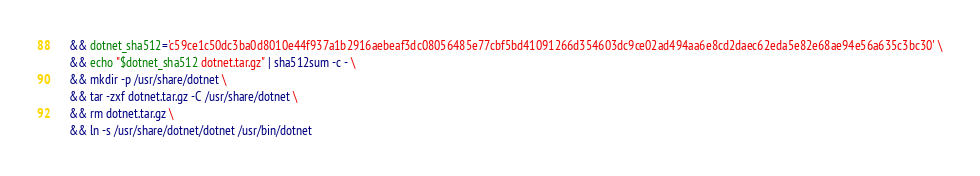Convert code to text. <code><loc_0><loc_0><loc_500><loc_500><_Dockerfile_>    && dotnet_sha512='c59ce1c50dc3ba0d8010e44f937a1b2916aebeaf3dc08056485e77cbf5bd41091266d354603dc9ce02ad494aa6e8cd2daec62eda5e82e68ae94e56a635c3bc30' \
    && echo "$dotnet_sha512 dotnet.tar.gz" | sha512sum -c - \
    && mkdir -p /usr/share/dotnet \
    && tar -zxf dotnet.tar.gz -C /usr/share/dotnet \
    && rm dotnet.tar.gz \
    && ln -s /usr/share/dotnet/dotnet /usr/bin/dotnet
</code> 